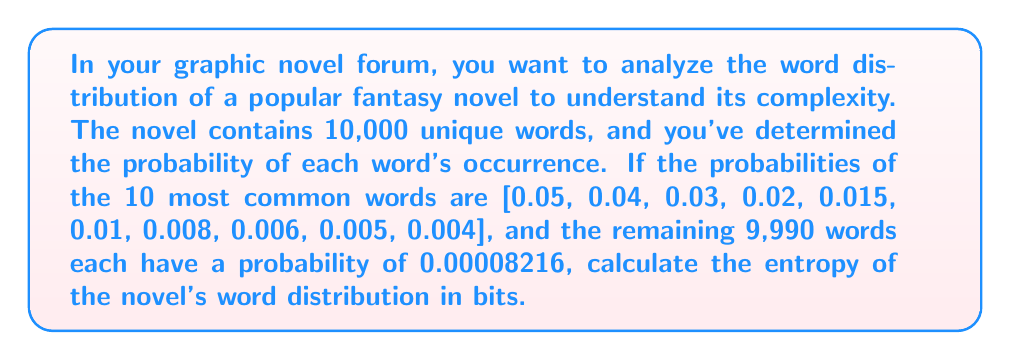Teach me how to tackle this problem. To calculate the entropy of the word distribution, we'll use the Shannon entropy formula:

$$S = -\sum_{i=1}^{N} p_i \log_2(p_i)$$

Where $S$ is the entropy, $p_i$ is the probability of each word, and $N$ is the total number of unique words.

Step 1: Calculate the entropy contribution of the 10 most common words.
$$S_1 = -[(0.05 \log_2 0.05) + (0.04 \log_2 0.04) + ... + (0.004 \log_2 0.004)]$$
$$S_1 = 0.21575 + 0.18617 + 0.15202 + 0.11328 + 0.09053 + 0.06644 + 0.05565 + 0.04443 + 0.03838 + 0.03185$$
$$S_1 = 0.9945 \text{ bits}$$

Step 2: Calculate the entropy contribution of the remaining 9,990 words.
$$S_2 = -9990 \times (0.00008216 \log_2 0.00008216)$$
$$S_2 = 9990 \times 0.00108 = 10.7892 \text{ bits}$$

Step 3: Sum the entropy contributions.
$$S_{\text{total}} = S_1 + S_2 = 0.9945 + 10.7892 = 11.7837 \text{ bits}$$
Answer: 11.7837 bits 